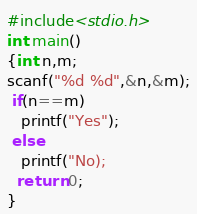<code> <loc_0><loc_0><loc_500><loc_500><_C_>#include<stdio.h>
int main()
{int n,m;
scanf("%d %d",&n,&m);
 if(n==m)
   printf("Yes");
 else
   printf("No);
  return 0;
}</code> 